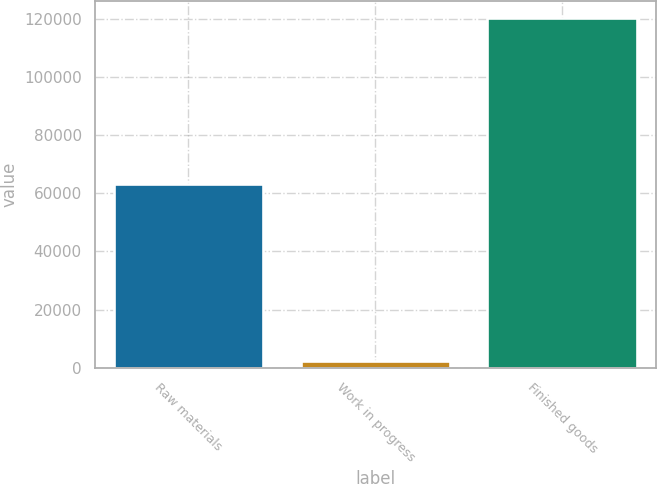<chart> <loc_0><loc_0><loc_500><loc_500><bar_chart><fcel>Raw materials<fcel>Work in progress<fcel>Finished goods<nl><fcel>63120<fcel>2427<fcel>120095<nl></chart> 